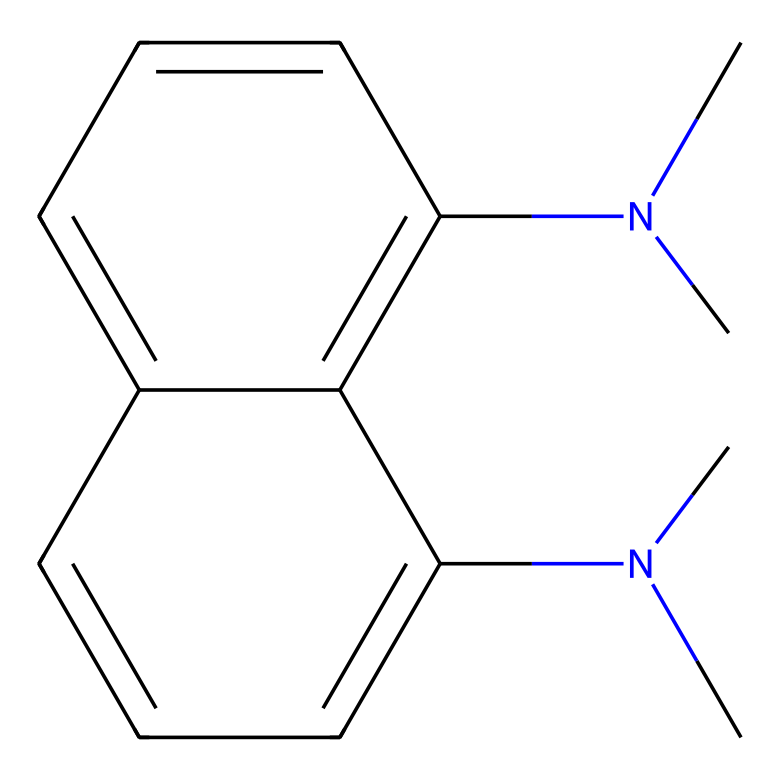What is the molecular formula of this chemical? To find the molecular formula, count the number of each type of atom present in the structure. The SMILES provided indicates there are 17 carbon (C) atoms and 22 hydrogen (H) atoms, and 2 nitrogen (N) atoms. Therefore, the molecular formula is C17H22N2.
Answer: C17H22N2 How many rings are present in this molecule? The structure shows two interconnected cyclic arrangements, indicating that there are two rings formed by the carbon atoms. By following the branches in the SMILES notation, the cyclic nature becomes evident.
Answer: 2 What type of base does this compound represent? This compound is classified as a superbase, which is characterized by its ability to deprotonate weakly acidic substrates and thus significantly raise pH levels in a solution. The presence of nitrogen atoms and their placement in the structure support this classification.
Answer: superbase How many nitrogen atoms are in this compound? The SMILES representation directly indicates two nitrogen (N) atoms present in the structure. Counting them within the structure confirms they are specifically placed in methyl groups.
Answer: 2 What functional groups are likely present in this molecular structure? The structure reveals tertiary amines due to the nitrogen atoms being bonded to three carbon groups. Additionally, no other functional groups like hydroxyl or carboxyl appear in this SMILES representation indicating the central functional characteristic is associated with amine groups.
Answer: amines What role do proton sponges play in soil acid-base chemistry? Proton sponges like this superbase can absorb protons when soil becomes acidic, thereby helping to regulate soil pH and maintain soil health, which is crucial for plant growth and ecological balance.
Answer: regulate soil pH 